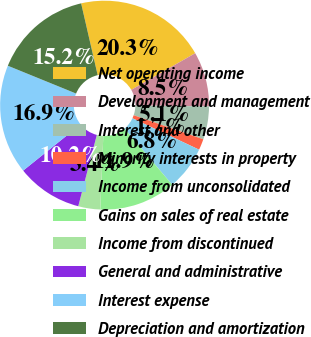Convert chart. <chart><loc_0><loc_0><loc_500><loc_500><pie_chart><fcel>Net operating income<fcel>Development and management<fcel>Interest and other<fcel>Minority interests in property<fcel>Income from unconsolidated<fcel>Gains on sales of real estate<fcel>Income from discontinued<fcel>General and administrative<fcel>Interest expense<fcel>Depreciation and amortization<nl><fcel>20.32%<fcel>8.48%<fcel>5.1%<fcel>1.71%<fcel>6.79%<fcel>11.86%<fcel>3.4%<fcel>10.17%<fcel>16.93%<fcel>15.24%<nl></chart> 